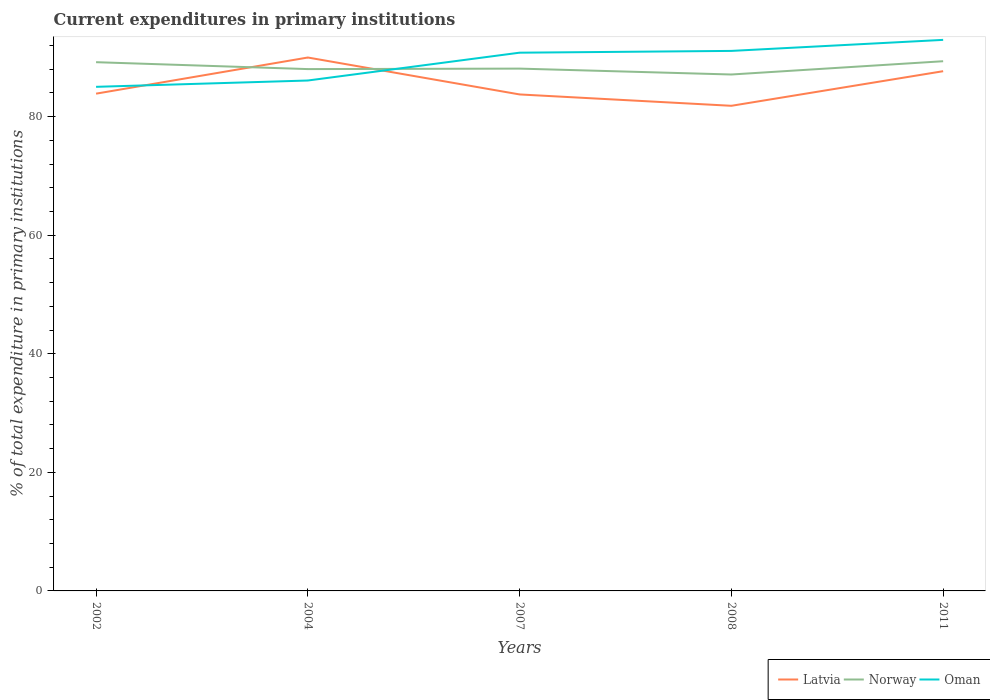Is the number of lines equal to the number of legend labels?
Give a very brief answer. Yes. Across all years, what is the maximum current expenditures in primary institutions in Oman?
Provide a succinct answer. 85.02. What is the total current expenditures in primary institutions in Oman in the graph?
Offer a very short reply. -0.3. What is the difference between the highest and the second highest current expenditures in primary institutions in Norway?
Your answer should be compact. 2.24. Is the current expenditures in primary institutions in Norway strictly greater than the current expenditures in primary institutions in Latvia over the years?
Your answer should be compact. No. How many lines are there?
Your answer should be very brief. 3. Are the values on the major ticks of Y-axis written in scientific E-notation?
Your response must be concise. No. Does the graph contain any zero values?
Offer a very short reply. No. Does the graph contain grids?
Provide a short and direct response. No. Where does the legend appear in the graph?
Keep it short and to the point. Bottom right. How are the legend labels stacked?
Offer a very short reply. Horizontal. What is the title of the graph?
Ensure brevity in your answer.  Current expenditures in primary institutions. What is the label or title of the X-axis?
Give a very brief answer. Years. What is the label or title of the Y-axis?
Provide a succinct answer. % of total expenditure in primary institutions. What is the % of total expenditure in primary institutions in Latvia in 2002?
Your answer should be very brief. 83.87. What is the % of total expenditure in primary institutions in Norway in 2002?
Keep it short and to the point. 89.18. What is the % of total expenditure in primary institutions in Oman in 2002?
Offer a terse response. 85.02. What is the % of total expenditure in primary institutions in Latvia in 2004?
Make the answer very short. 89.97. What is the % of total expenditure in primary institutions in Norway in 2004?
Provide a succinct answer. 88.01. What is the % of total expenditure in primary institutions of Oman in 2004?
Your answer should be compact. 86.09. What is the % of total expenditure in primary institutions of Latvia in 2007?
Your answer should be compact. 83.74. What is the % of total expenditure in primary institutions of Norway in 2007?
Keep it short and to the point. 88.1. What is the % of total expenditure in primary institutions in Oman in 2007?
Ensure brevity in your answer.  90.78. What is the % of total expenditure in primary institutions of Latvia in 2008?
Give a very brief answer. 81.82. What is the % of total expenditure in primary institutions in Norway in 2008?
Provide a short and direct response. 87.1. What is the % of total expenditure in primary institutions of Oman in 2008?
Provide a succinct answer. 91.08. What is the % of total expenditure in primary institutions in Latvia in 2011?
Your answer should be very brief. 87.66. What is the % of total expenditure in primary institutions in Norway in 2011?
Ensure brevity in your answer.  89.34. What is the % of total expenditure in primary institutions in Oman in 2011?
Your response must be concise. 92.94. Across all years, what is the maximum % of total expenditure in primary institutions of Latvia?
Your answer should be compact. 89.97. Across all years, what is the maximum % of total expenditure in primary institutions in Norway?
Your answer should be compact. 89.34. Across all years, what is the maximum % of total expenditure in primary institutions in Oman?
Give a very brief answer. 92.94. Across all years, what is the minimum % of total expenditure in primary institutions in Latvia?
Offer a terse response. 81.82. Across all years, what is the minimum % of total expenditure in primary institutions of Norway?
Your response must be concise. 87.1. Across all years, what is the minimum % of total expenditure in primary institutions in Oman?
Your response must be concise. 85.02. What is the total % of total expenditure in primary institutions of Latvia in the graph?
Make the answer very short. 427.06. What is the total % of total expenditure in primary institutions of Norway in the graph?
Offer a very short reply. 441.73. What is the total % of total expenditure in primary institutions of Oman in the graph?
Offer a terse response. 445.92. What is the difference between the % of total expenditure in primary institutions of Latvia in 2002 and that in 2004?
Ensure brevity in your answer.  -6.1. What is the difference between the % of total expenditure in primary institutions in Norway in 2002 and that in 2004?
Provide a short and direct response. 1.17. What is the difference between the % of total expenditure in primary institutions in Oman in 2002 and that in 2004?
Give a very brief answer. -1.07. What is the difference between the % of total expenditure in primary institutions of Latvia in 2002 and that in 2007?
Provide a short and direct response. 0.13. What is the difference between the % of total expenditure in primary institutions of Norway in 2002 and that in 2007?
Provide a succinct answer. 1.08. What is the difference between the % of total expenditure in primary institutions in Oman in 2002 and that in 2007?
Your answer should be very brief. -5.76. What is the difference between the % of total expenditure in primary institutions in Latvia in 2002 and that in 2008?
Give a very brief answer. 2.05. What is the difference between the % of total expenditure in primary institutions of Norway in 2002 and that in 2008?
Your response must be concise. 2.08. What is the difference between the % of total expenditure in primary institutions of Oman in 2002 and that in 2008?
Give a very brief answer. -6.06. What is the difference between the % of total expenditure in primary institutions of Latvia in 2002 and that in 2011?
Offer a very short reply. -3.79. What is the difference between the % of total expenditure in primary institutions in Norway in 2002 and that in 2011?
Provide a short and direct response. -0.16. What is the difference between the % of total expenditure in primary institutions of Oman in 2002 and that in 2011?
Offer a terse response. -7.92. What is the difference between the % of total expenditure in primary institutions in Latvia in 2004 and that in 2007?
Provide a short and direct response. 6.23. What is the difference between the % of total expenditure in primary institutions in Norway in 2004 and that in 2007?
Your answer should be compact. -0.08. What is the difference between the % of total expenditure in primary institutions in Oman in 2004 and that in 2007?
Keep it short and to the point. -4.69. What is the difference between the % of total expenditure in primary institutions of Latvia in 2004 and that in 2008?
Your response must be concise. 8.14. What is the difference between the % of total expenditure in primary institutions in Norway in 2004 and that in 2008?
Offer a very short reply. 0.91. What is the difference between the % of total expenditure in primary institutions of Oman in 2004 and that in 2008?
Your answer should be compact. -4.99. What is the difference between the % of total expenditure in primary institutions in Latvia in 2004 and that in 2011?
Provide a succinct answer. 2.31. What is the difference between the % of total expenditure in primary institutions in Norway in 2004 and that in 2011?
Offer a terse response. -1.33. What is the difference between the % of total expenditure in primary institutions in Oman in 2004 and that in 2011?
Provide a succinct answer. -6.86. What is the difference between the % of total expenditure in primary institutions in Latvia in 2007 and that in 2008?
Your response must be concise. 1.92. What is the difference between the % of total expenditure in primary institutions in Oman in 2007 and that in 2008?
Your answer should be compact. -0.3. What is the difference between the % of total expenditure in primary institutions of Latvia in 2007 and that in 2011?
Give a very brief answer. -3.92. What is the difference between the % of total expenditure in primary institutions in Norway in 2007 and that in 2011?
Your answer should be compact. -1.24. What is the difference between the % of total expenditure in primary institutions in Oman in 2007 and that in 2011?
Provide a short and direct response. -2.16. What is the difference between the % of total expenditure in primary institutions in Latvia in 2008 and that in 2011?
Provide a succinct answer. -5.84. What is the difference between the % of total expenditure in primary institutions of Norway in 2008 and that in 2011?
Make the answer very short. -2.24. What is the difference between the % of total expenditure in primary institutions of Oman in 2008 and that in 2011?
Keep it short and to the point. -1.86. What is the difference between the % of total expenditure in primary institutions in Latvia in 2002 and the % of total expenditure in primary institutions in Norway in 2004?
Offer a terse response. -4.14. What is the difference between the % of total expenditure in primary institutions of Latvia in 2002 and the % of total expenditure in primary institutions of Oman in 2004?
Your answer should be very brief. -2.22. What is the difference between the % of total expenditure in primary institutions of Norway in 2002 and the % of total expenditure in primary institutions of Oman in 2004?
Keep it short and to the point. 3.09. What is the difference between the % of total expenditure in primary institutions in Latvia in 2002 and the % of total expenditure in primary institutions in Norway in 2007?
Your answer should be very brief. -4.23. What is the difference between the % of total expenditure in primary institutions in Latvia in 2002 and the % of total expenditure in primary institutions in Oman in 2007?
Offer a terse response. -6.91. What is the difference between the % of total expenditure in primary institutions in Norway in 2002 and the % of total expenditure in primary institutions in Oman in 2007?
Give a very brief answer. -1.6. What is the difference between the % of total expenditure in primary institutions of Latvia in 2002 and the % of total expenditure in primary institutions of Norway in 2008?
Give a very brief answer. -3.23. What is the difference between the % of total expenditure in primary institutions in Latvia in 2002 and the % of total expenditure in primary institutions in Oman in 2008?
Make the answer very short. -7.21. What is the difference between the % of total expenditure in primary institutions of Norway in 2002 and the % of total expenditure in primary institutions of Oman in 2008?
Your response must be concise. -1.9. What is the difference between the % of total expenditure in primary institutions in Latvia in 2002 and the % of total expenditure in primary institutions in Norway in 2011?
Make the answer very short. -5.47. What is the difference between the % of total expenditure in primary institutions of Latvia in 2002 and the % of total expenditure in primary institutions of Oman in 2011?
Your answer should be compact. -9.07. What is the difference between the % of total expenditure in primary institutions in Norway in 2002 and the % of total expenditure in primary institutions in Oman in 2011?
Provide a succinct answer. -3.76. What is the difference between the % of total expenditure in primary institutions of Latvia in 2004 and the % of total expenditure in primary institutions of Norway in 2007?
Your answer should be very brief. 1.87. What is the difference between the % of total expenditure in primary institutions in Latvia in 2004 and the % of total expenditure in primary institutions in Oman in 2007?
Offer a very short reply. -0.81. What is the difference between the % of total expenditure in primary institutions of Norway in 2004 and the % of total expenditure in primary institutions of Oman in 2007?
Make the answer very short. -2.77. What is the difference between the % of total expenditure in primary institutions of Latvia in 2004 and the % of total expenditure in primary institutions of Norway in 2008?
Ensure brevity in your answer.  2.87. What is the difference between the % of total expenditure in primary institutions of Latvia in 2004 and the % of total expenditure in primary institutions of Oman in 2008?
Provide a short and direct response. -1.12. What is the difference between the % of total expenditure in primary institutions in Norway in 2004 and the % of total expenditure in primary institutions in Oman in 2008?
Provide a succinct answer. -3.07. What is the difference between the % of total expenditure in primary institutions of Latvia in 2004 and the % of total expenditure in primary institutions of Norway in 2011?
Your answer should be compact. 0.63. What is the difference between the % of total expenditure in primary institutions of Latvia in 2004 and the % of total expenditure in primary institutions of Oman in 2011?
Ensure brevity in your answer.  -2.98. What is the difference between the % of total expenditure in primary institutions in Norway in 2004 and the % of total expenditure in primary institutions in Oman in 2011?
Your response must be concise. -4.93. What is the difference between the % of total expenditure in primary institutions in Latvia in 2007 and the % of total expenditure in primary institutions in Norway in 2008?
Offer a very short reply. -3.36. What is the difference between the % of total expenditure in primary institutions of Latvia in 2007 and the % of total expenditure in primary institutions of Oman in 2008?
Provide a short and direct response. -7.34. What is the difference between the % of total expenditure in primary institutions in Norway in 2007 and the % of total expenditure in primary institutions in Oman in 2008?
Your response must be concise. -2.99. What is the difference between the % of total expenditure in primary institutions in Latvia in 2007 and the % of total expenditure in primary institutions in Norway in 2011?
Your answer should be very brief. -5.6. What is the difference between the % of total expenditure in primary institutions in Latvia in 2007 and the % of total expenditure in primary institutions in Oman in 2011?
Your answer should be compact. -9.2. What is the difference between the % of total expenditure in primary institutions in Norway in 2007 and the % of total expenditure in primary institutions in Oman in 2011?
Keep it short and to the point. -4.85. What is the difference between the % of total expenditure in primary institutions in Latvia in 2008 and the % of total expenditure in primary institutions in Norway in 2011?
Keep it short and to the point. -7.52. What is the difference between the % of total expenditure in primary institutions in Latvia in 2008 and the % of total expenditure in primary institutions in Oman in 2011?
Your answer should be compact. -11.12. What is the difference between the % of total expenditure in primary institutions in Norway in 2008 and the % of total expenditure in primary institutions in Oman in 2011?
Offer a terse response. -5.84. What is the average % of total expenditure in primary institutions in Latvia per year?
Offer a very short reply. 85.41. What is the average % of total expenditure in primary institutions of Norway per year?
Make the answer very short. 88.35. What is the average % of total expenditure in primary institutions in Oman per year?
Your answer should be very brief. 89.18. In the year 2002, what is the difference between the % of total expenditure in primary institutions in Latvia and % of total expenditure in primary institutions in Norway?
Make the answer very short. -5.31. In the year 2002, what is the difference between the % of total expenditure in primary institutions in Latvia and % of total expenditure in primary institutions in Oman?
Provide a short and direct response. -1.15. In the year 2002, what is the difference between the % of total expenditure in primary institutions of Norway and % of total expenditure in primary institutions of Oman?
Make the answer very short. 4.16. In the year 2004, what is the difference between the % of total expenditure in primary institutions of Latvia and % of total expenditure in primary institutions of Norway?
Provide a succinct answer. 1.95. In the year 2004, what is the difference between the % of total expenditure in primary institutions of Latvia and % of total expenditure in primary institutions of Oman?
Keep it short and to the point. 3.88. In the year 2004, what is the difference between the % of total expenditure in primary institutions of Norway and % of total expenditure in primary institutions of Oman?
Keep it short and to the point. 1.93. In the year 2007, what is the difference between the % of total expenditure in primary institutions of Latvia and % of total expenditure in primary institutions of Norway?
Ensure brevity in your answer.  -4.36. In the year 2007, what is the difference between the % of total expenditure in primary institutions of Latvia and % of total expenditure in primary institutions of Oman?
Provide a short and direct response. -7.04. In the year 2007, what is the difference between the % of total expenditure in primary institutions of Norway and % of total expenditure in primary institutions of Oman?
Provide a succinct answer. -2.69. In the year 2008, what is the difference between the % of total expenditure in primary institutions of Latvia and % of total expenditure in primary institutions of Norway?
Offer a terse response. -5.28. In the year 2008, what is the difference between the % of total expenditure in primary institutions of Latvia and % of total expenditure in primary institutions of Oman?
Keep it short and to the point. -9.26. In the year 2008, what is the difference between the % of total expenditure in primary institutions in Norway and % of total expenditure in primary institutions in Oman?
Make the answer very short. -3.98. In the year 2011, what is the difference between the % of total expenditure in primary institutions in Latvia and % of total expenditure in primary institutions in Norway?
Give a very brief answer. -1.68. In the year 2011, what is the difference between the % of total expenditure in primary institutions in Latvia and % of total expenditure in primary institutions in Oman?
Your response must be concise. -5.28. In the year 2011, what is the difference between the % of total expenditure in primary institutions in Norway and % of total expenditure in primary institutions in Oman?
Your answer should be very brief. -3.6. What is the ratio of the % of total expenditure in primary institutions in Latvia in 2002 to that in 2004?
Your answer should be very brief. 0.93. What is the ratio of the % of total expenditure in primary institutions in Norway in 2002 to that in 2004?
Make the answer very short. 1.01. What is the ratio of the % of total expenditure in primary institutions in Oman in 2002 to that in 2004?
Offer a very short reply. 0.99. What is the ratio of the % of total expenditure in primary institutions in Latvia in 2002 to that in 2007?
Your answer should be compact. 1. What is the ratio of the % of total expenditure in primary institutions of Norway in 2002 to that in 2007?
Your response must be concise. 1.01. What is the ratio of the % of total expenditure in primary institutions of Oman in 2002 to that in 2007?
Give a very brief answer. 0.94. What is the ratio of the % of total expenditure in primary institutions in Latvia in 2002 to that in 2008?
Your answer should be compact. 1.02. What is the ratio of the % of total expenditure in primary institutions in Norway in 2002 to that in 2008?
Provide a succinct answer. 1.02. What is the ratio of the % of total expenditure in primary institutions of Oman in 2002 to that in 2008?
Your response must be concise. 0.93. What is the ratio of the % of total expenditure in primary institutions of Latvia in 2002 to that in 2011?
Your response must be concise. 0.96. What is the ratio of the % of total expenditure in primary institutions of Norway in 2002 to that in 2011?
Offer a very short reply. 1. What is the ratio of the % of total expenditure in primary institutions in Oman in 2002 to that in 2011?
Provide a short and direct response. 0.91. What is the ratio of the % of total expenditure in primary institutions in Latvia in 2004 to that in 2007?
Offer a terse response. 1.07. What is the ratio of the % of total expenditure in primary institutions of Oman in 2004 to that in 2007?
Provide a short and direct response. 0.95. What is the ratio of the % of total expenditure in primary institutions of Latvia in 2004 to that in 2008?
Offer a very short reply. 1.1. What is the ratio of the % of total expenditure in primary institutions of Norway in 2004 to that in 2008?
Ensure brevity in your answer.  1.01. What is the ratio of the % of total expenditure in primary institutions of Oman in 2004 to that in 2008?
Keep it short and to the point. 0.95. What is the ratio of the % of total expenditure in primary institutions in Latvia in 2004 to that in 2011?
Provide a short and direct response. 1.03. What is the ratio of the % of total expenditure in primary institutions of Norway in 2004 to that in 2011?
Your answer should be very brief. 0.99. What is the ratio of the % of total expenditure in primary institutions in Oman in 2004 to that in 2011?
Provide a succinct answer. 0.93. What is the ratio of the % of total expenditure in primary institutions in Latvia in 2007 to that in 2008?
Offer a terse response. 1.02. What is the ratio of the % of total expenditure in primary institutions in Norway in 2007 to that in 2008?
Give a very brief answer. 1.01. What is the ratio of the % of total expenditure in primary institutions of Oman in 2007 to that in 2008?
Keep it short and to the point. 1. What is the ratio of the % of total expenditure in primary institutions of Latvia in 2007 to that in 2011?
Your answer should be compact. 0.96. What is the ratio of the % of total expenditure in primary institutions of Norway in 2007 to that in 2011?
Keep it short and to the point. 0.99. What is the ratio of the % of total expenditure in primary institutions of Oman in 2007 to that in 2011?
Your answer should be compact. 0.98. What is the ratio of the % of total expenditure in primary institutions of Latvia in 2008 to that in 2011?
Provide a short and direct response. 0.93. What is the ratio of the % of total expenditure in primary institutions of Norway in 2008 to that in 2011?
Ensure brevity in your answer.  0.97. What is the ratio of the % of total expenditure in primary institutions in Oman in 2008 to that in 2011?
Provide a succinct answer. 0.98. What is the difference between the highest and the second highest % of total expenditure in primary institutions of Latvia?
Your response must be concise. 2.31. What is the difference between the highest and the second highest % of total expenditure in primary institutions of Norway?
Your answer should be compact. 0.16. What is the difference between the highest and the second highest % of total expenditure in primary institutions of Oman?
Provide a succinct answer. 1.86. What is the difference between the highest and the lowest % of total expenditure in primary institutions in Latvia?
Your response must be concise. 8.14. What is the difference between the highest and the lowest % of total expenditure in primary institutions of Norway?
Keep it short and to the point. 2.24. What is the difference between the highest and the lowest % of total expenditure in primary institutions of Oman?
Your response must be concise. 7.92. 